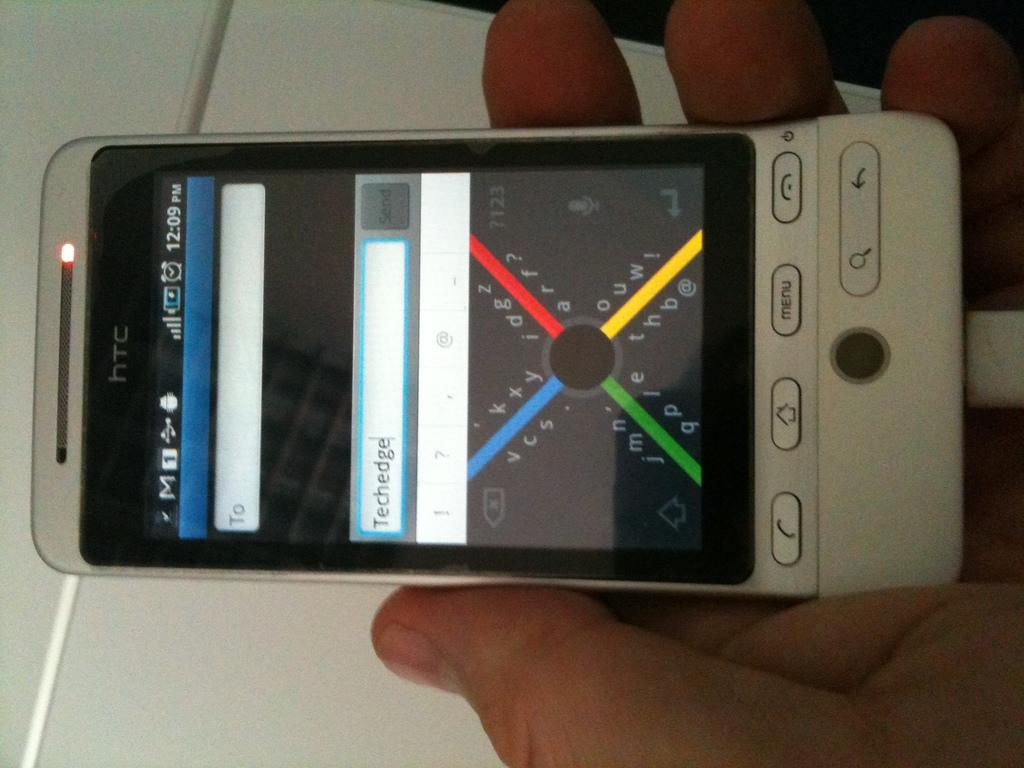<image>
Give a short and clear explanation of the subsequent image. A grey smartphone with a red, blue, green and yellow X on the screen that is being held. 